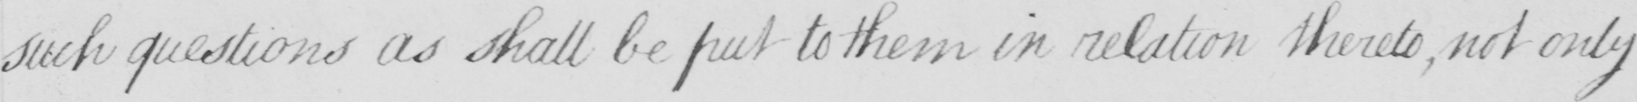Can you read and transcribe this handwriting? such questions as shall be put to them in relation thereto  , not only 